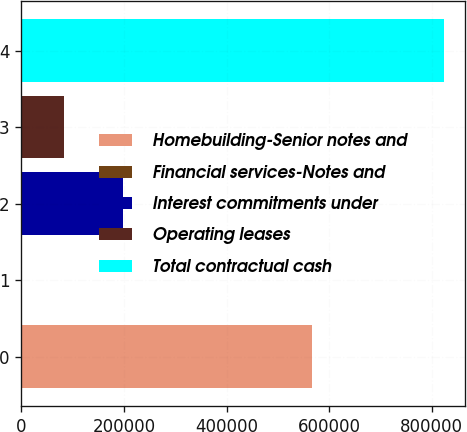<chart> <loc_0><loc_0><loc_500><loc_500><bar_chart><fcel>Homebuilding-Senior notes and<fcel>Financial services-Notes and<fcel>Interest commitments under<fcel>Operating leases<fcel>Total contractual cash<nl><fcel>567347<fcel>31<fcel>198041<fcel>82317.6<fcel>822897<nl></chart> 